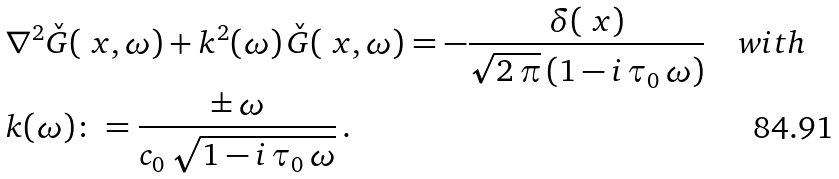Convert formula to latex. <formula><loc_0><loc_0><loc_500><loc_500>& \nabla ^ { 2 } \check { G } ( \ x , \omega ) + k ^ { 2 } ( \omega ) \, \check { G } ( \ x , \omega ) = - \frac { \delta ( \ x ) } { \sqrt { 2 \, \pi } \, ( 1 - i \, \tau _ { 0 } \, \omega ) } \quad w i t h \\ & k ( \omega ) \colon = \frac { \pm \, \omega } { c _ { 0 } \, \sqrt { 1 - i \, \tau _ { 0 } \, \omega } } \, .</formula> 